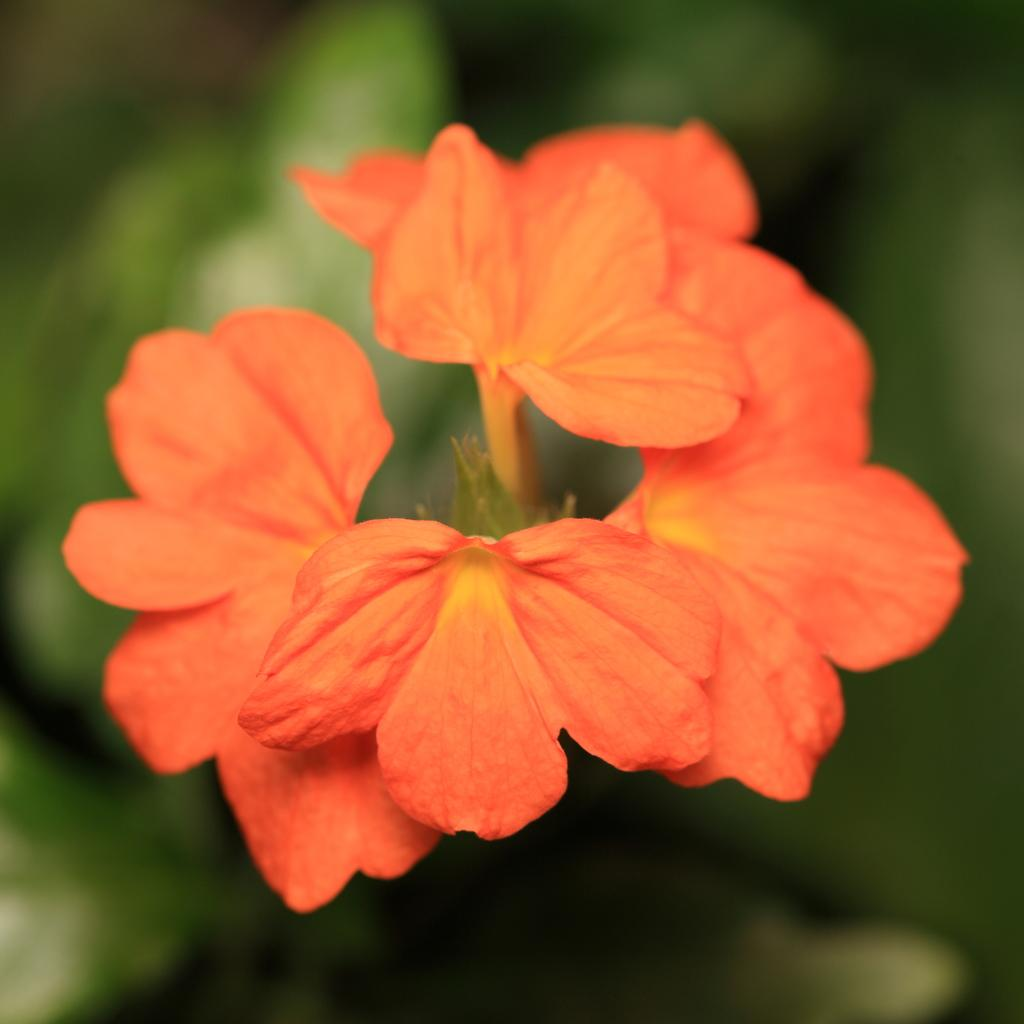What type of photography is used in the image? The image is a macro photography. What is the main subject of the macro photography? The main subject of the macro photography is orange color flowers. What type of spade is used to dig up the flowers in the image? There is no spade present in the image, as it is a macro photography of orange color flowers. What is the smell of the flowers in the image? The image is a photograph, so it does not have a smell. 